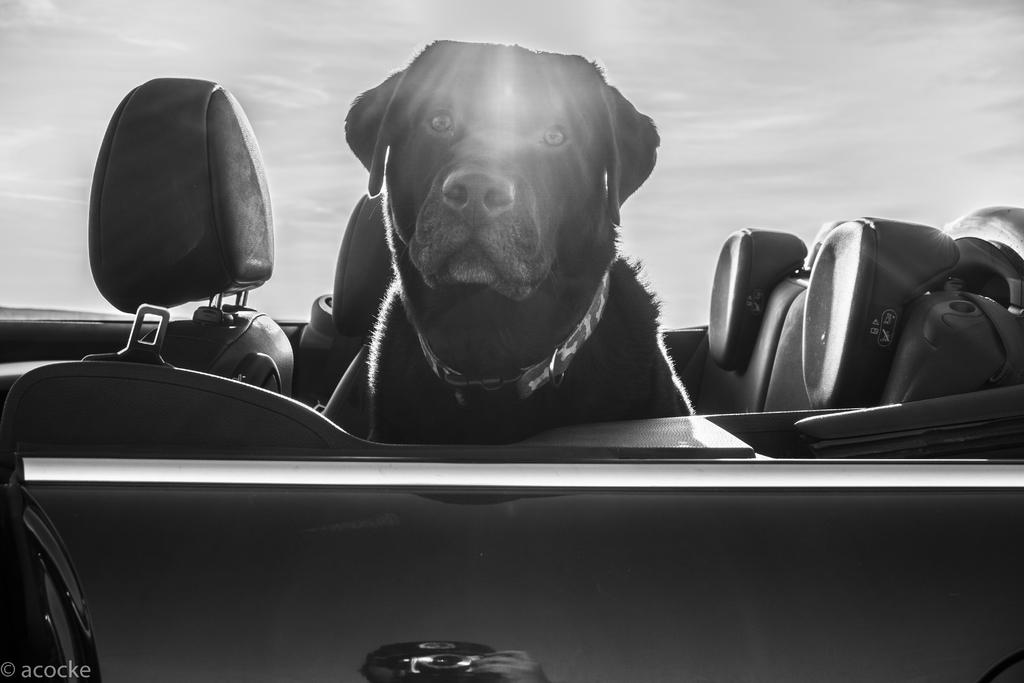What is the color scheme of the image? The image is black and white. What animal can be seen in the image? There is a dog in the image. Where is the dog located in the image? The dog is sitting in a car. What is present in the bottom left corner of the image? There is text in the bottom left corner of the image. How many birds are flying over the car in the image? There are no birds present in the image. What type of fire can be seen in the image? There is no fire present in the image. 